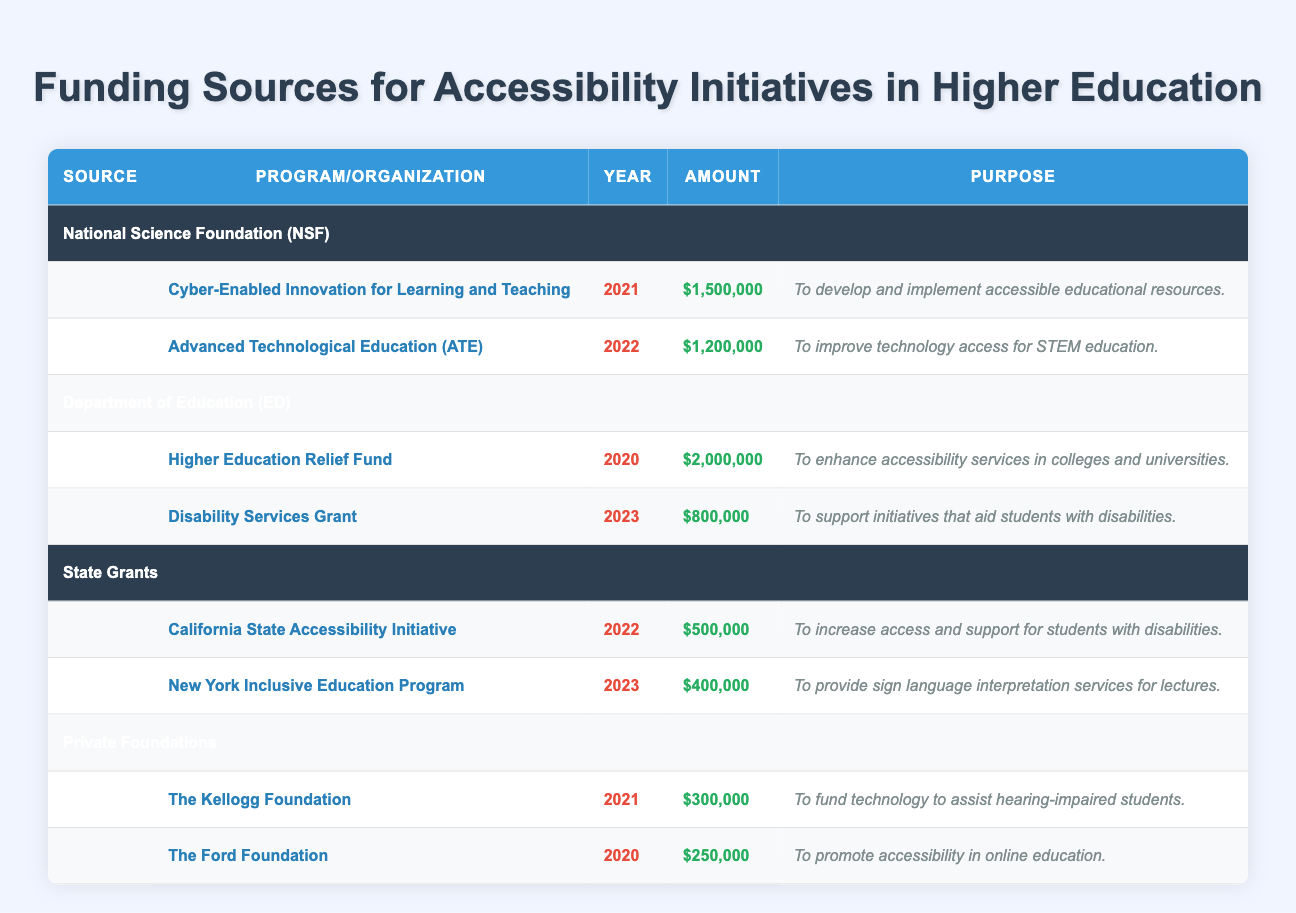What is the total amount funded by the National Science Foundation? The National Science Foundation has funded two programs: Cyber-Enabled Innovation for Learning and Teaching for $1,500,000 and Advanced Technological Education for $1,200,000. Summing these amounts gives $1,500,000 + $1,200,000 = $2,700,000.
Answer: $2,700,000 Which organization provided funding for sign language interpretation services in lectures? The New York Inclusive Education Program, which was funded by State Grants in 2023, specifically states its purpose is to provide sign language interpretation services for lectures.
Answer: State Grants How much funding did the Department of Education allocate for the Disability Services Grant in 2023? The Disability Services Grant was funded by the Department of Education in 2023, and the amount allocated was $800,000 as indicated in the table.
Answer: $800,000 Is the total funding amount from Private Foundations greater than $600,000? The total funding amount from Private Foundations includes $300,000 from The Kellogg Foundation and $250,000 from The Ford Foundation. Adding these gives $300,000 + $250,000 = $550,000, which is not greater than $600,000.
Answer: No What is the average funding amount for programs offered by the Department of Education? The Department of Education funded two programs: Higher Education Relief Fund for $2,000,000 and Disability Services Grant for $800,000. The total funding from these programs is $2,000,000 + $800,000 = $2,800,000, and there are 2 programs, so the average funding amount is $2,800,000 / 2 = $1,400,000.
Answer: $1,400,000 Which funding source had the highest single program allocation? The Department of Education's Higher Education Relief Fund received $2,000,000, which is the highest single program allocation listed in the table compared to all other funding sources.
Answer: Department of Education Calculate the total funding for accessibility initiatives in 2023. The funding data for 2023 includes $800,000 from the Disability Services Grant by the Department of Education and $400,000 from the New York Inclusive Education Program under State Grants. Adding these amounts together gives $800,000 + $400,000 = $1,200,000 for accessibility initiatives in that year.
Answer: $1,200,000 Did Private Foundations fund any initiatives related specifically to technology for students with disabilities? Yes, The Kellogg Foundation funded a program specifically aimed at providing technology assistance for hearing-impaired students with a grant of $300,000.
Answer: Yes How many accessibility initiatives were funded by State Grants in total? State Grants funded two initiatives: California State Accessibility Initiative ($500,000) and New York Inclusive Education Program ($400,000), totaling two programs aimed at accessibility for students.
Answer: 2 